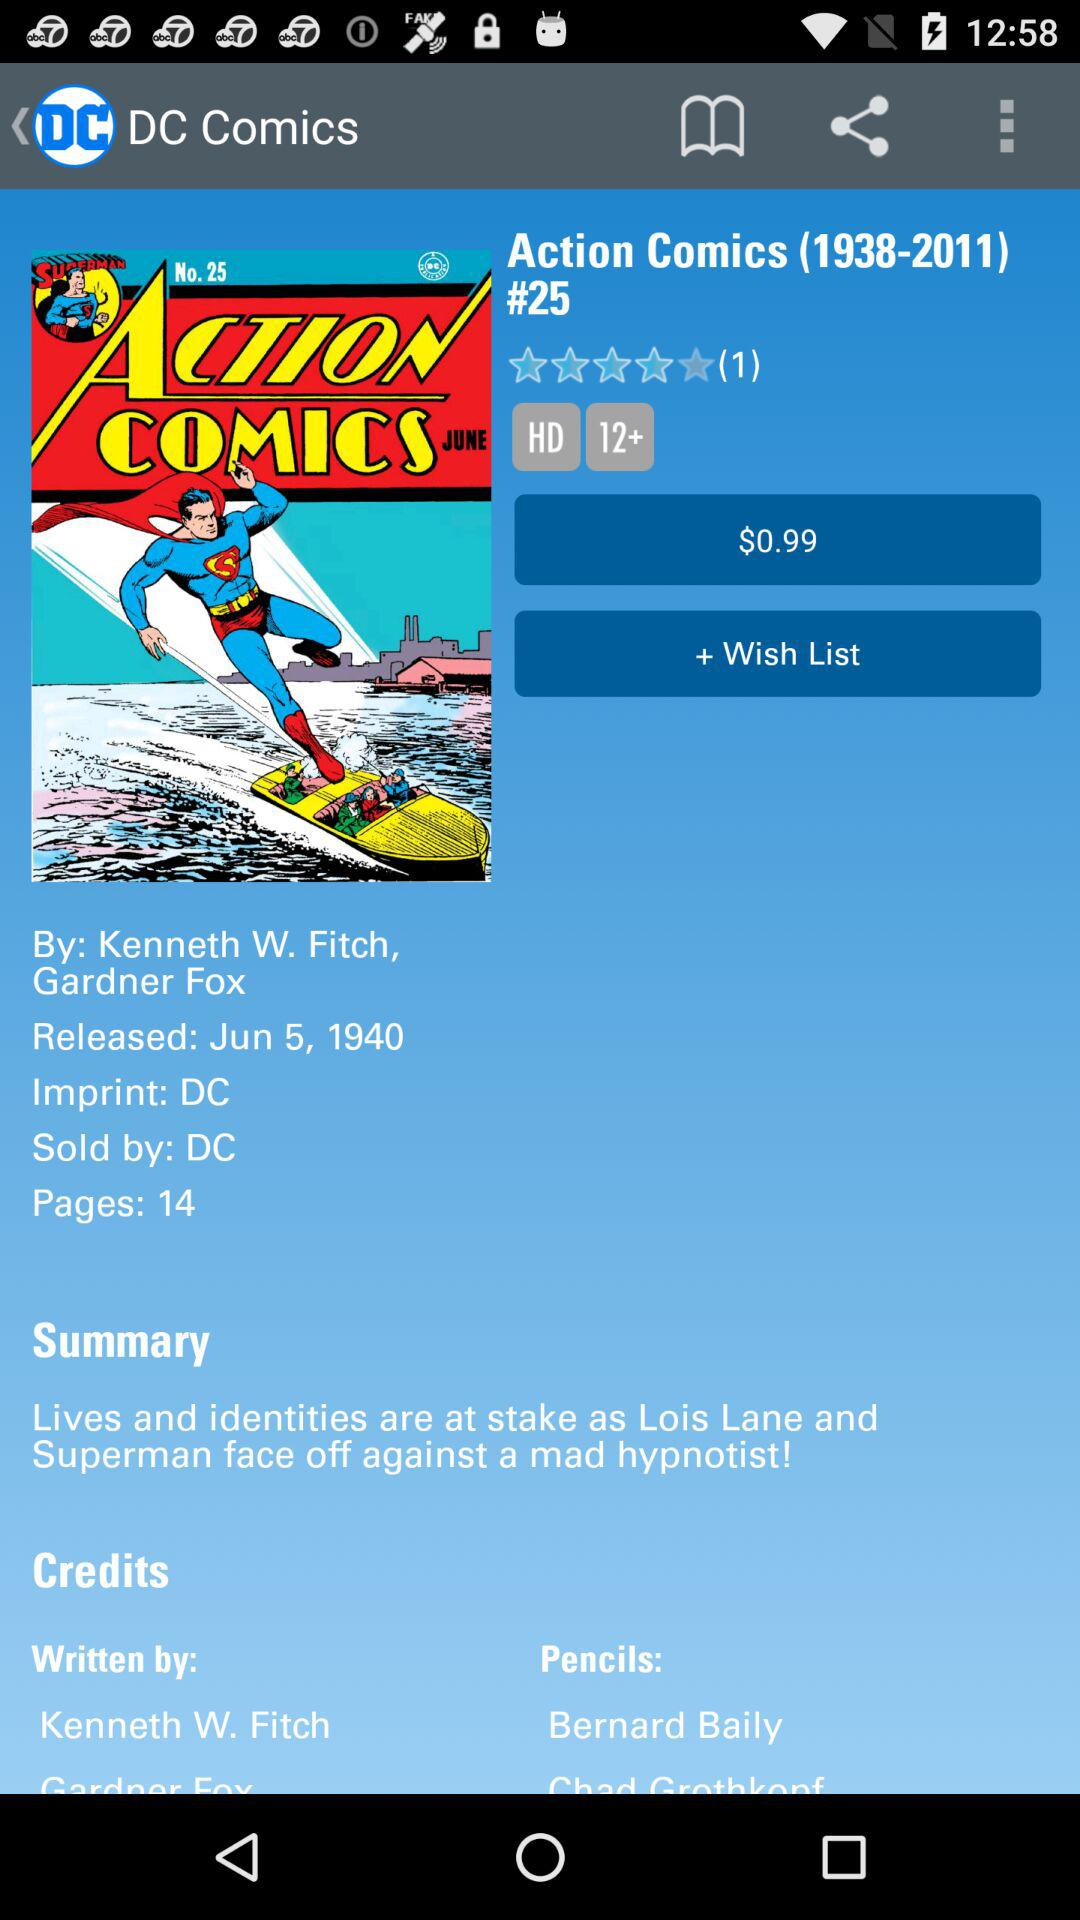How many pages are in action comics? There are 14 pages. 